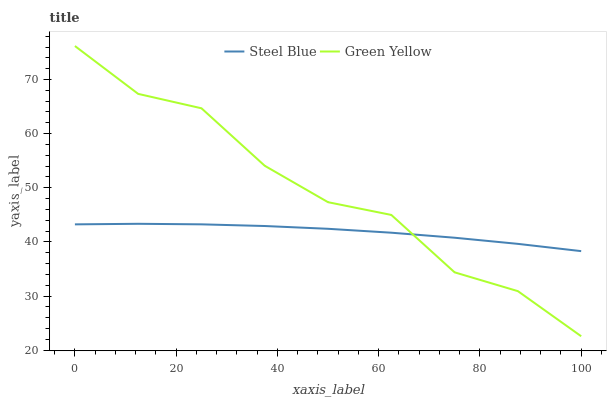Does Steel Blue have the maximum area under the curve?
Answer yes or no. No. Is Steel Blue the roughest?
Answer yes or no. No. Does Steel Blue have the lowest value?
Answer yes or no. No. Does Steel Blue have the highest value?
Answer yes or no. No. 